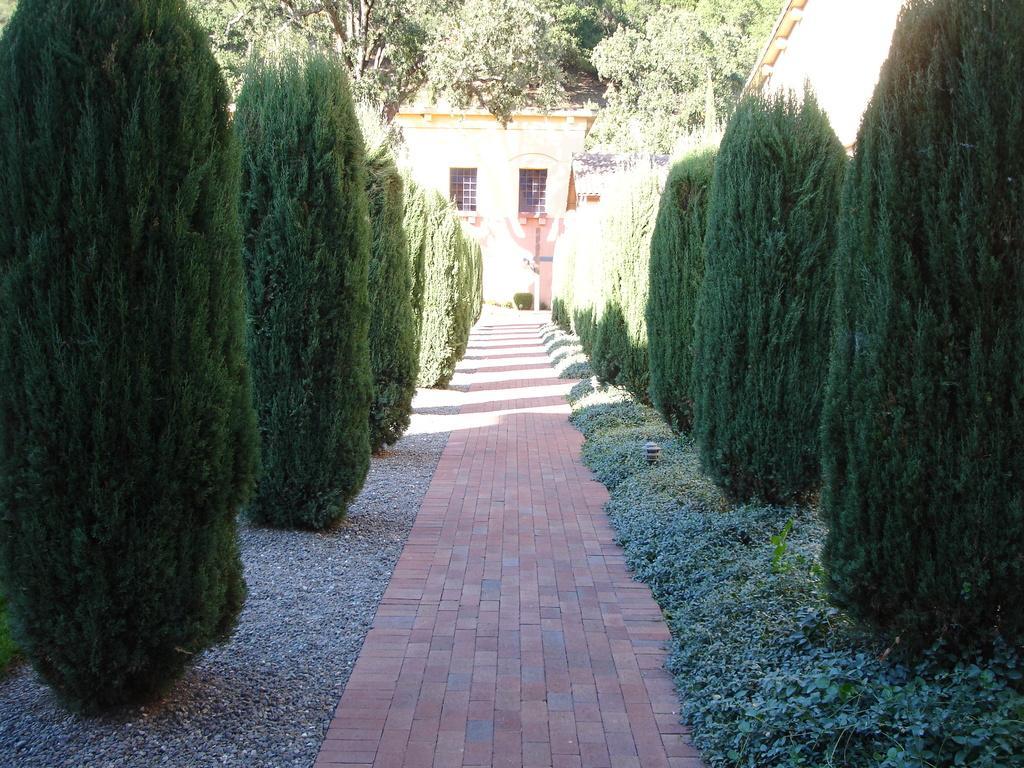Could you give a brief overview of what you see in this image? Here we can see plants and trees. In the background we can see a house and windows. 